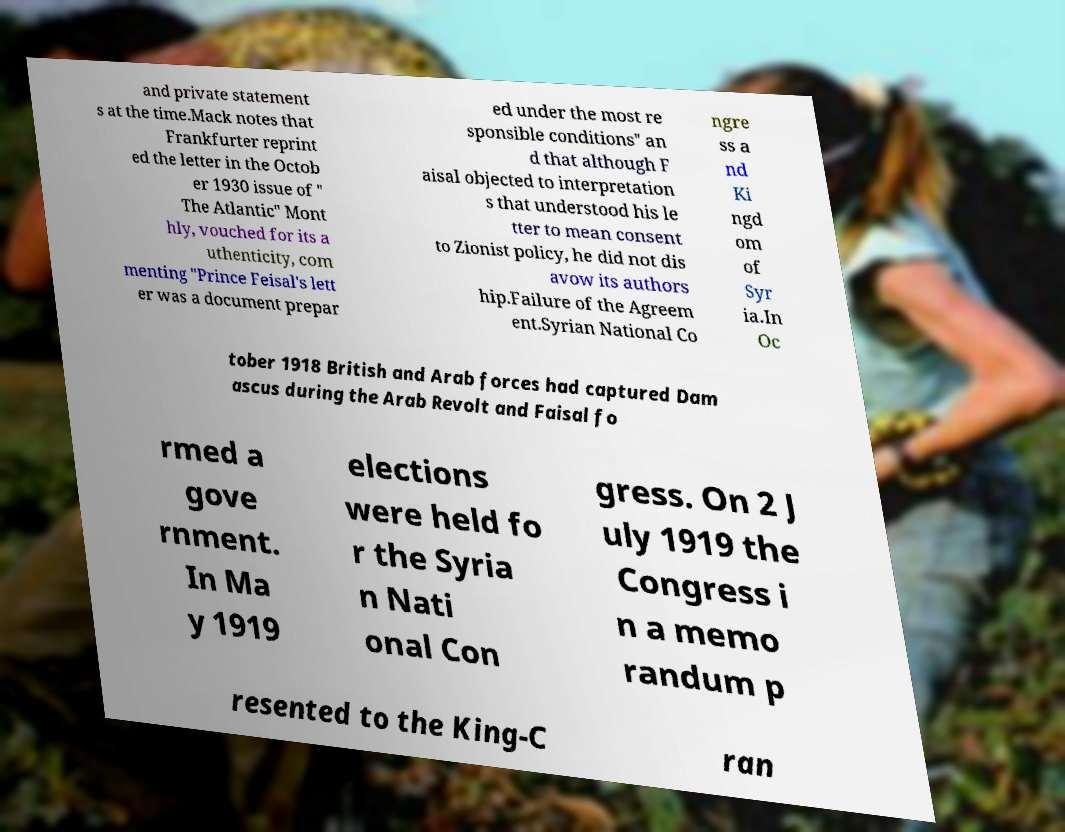For documentation purposes, I need the text within this image transcribed. Could you provide that? and private statement s at the time.Mack notes that Frankfurter reprint ed the letter in the Octob er 1930 issue of " The Atlantic" Mont hly, vouched for its a uthenticity, com menting "Prince Feisal's lett er was a document prepar ed under the most re sponsible conditions" an d that although F aisal objected to interpretation s that understood his le tter to mean consent to Zionist policy, he did not dis avow its authors hip.Failure of the Agreem ent.Syrian National Co ngre ss a nd Ki ngd om of Syr ia.In Oc tober 1918 British and Arab forces had captured Dam ascus during the Arab Revolt and Faisal fo rmed a gove rnment. In Ma y 1919 elections were held fo r the Syria n Nati onal Con gress. On 2 J uly 1919 the Congress i n a memo randum p resented to the King-C ran 